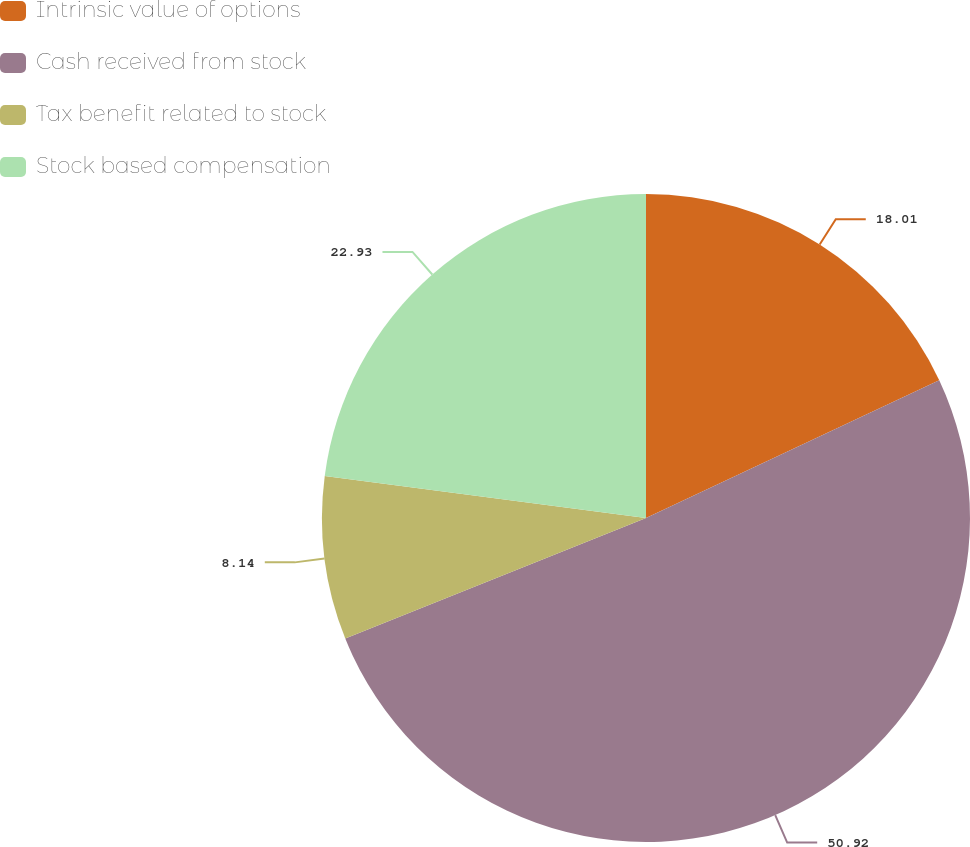Convert chart. <chart><loc_0><loc_0><loc_500><loc_500><pie_chart><fcel>Intrinsic value of options<fcel>Cash received from stock<fcel>Tax benefit related to stock<fcel>Stock based compensation<nl><fcel>18.01%<fcel>50.92%<fcel>8.14%<fcel>22.93%<nl></chart> 